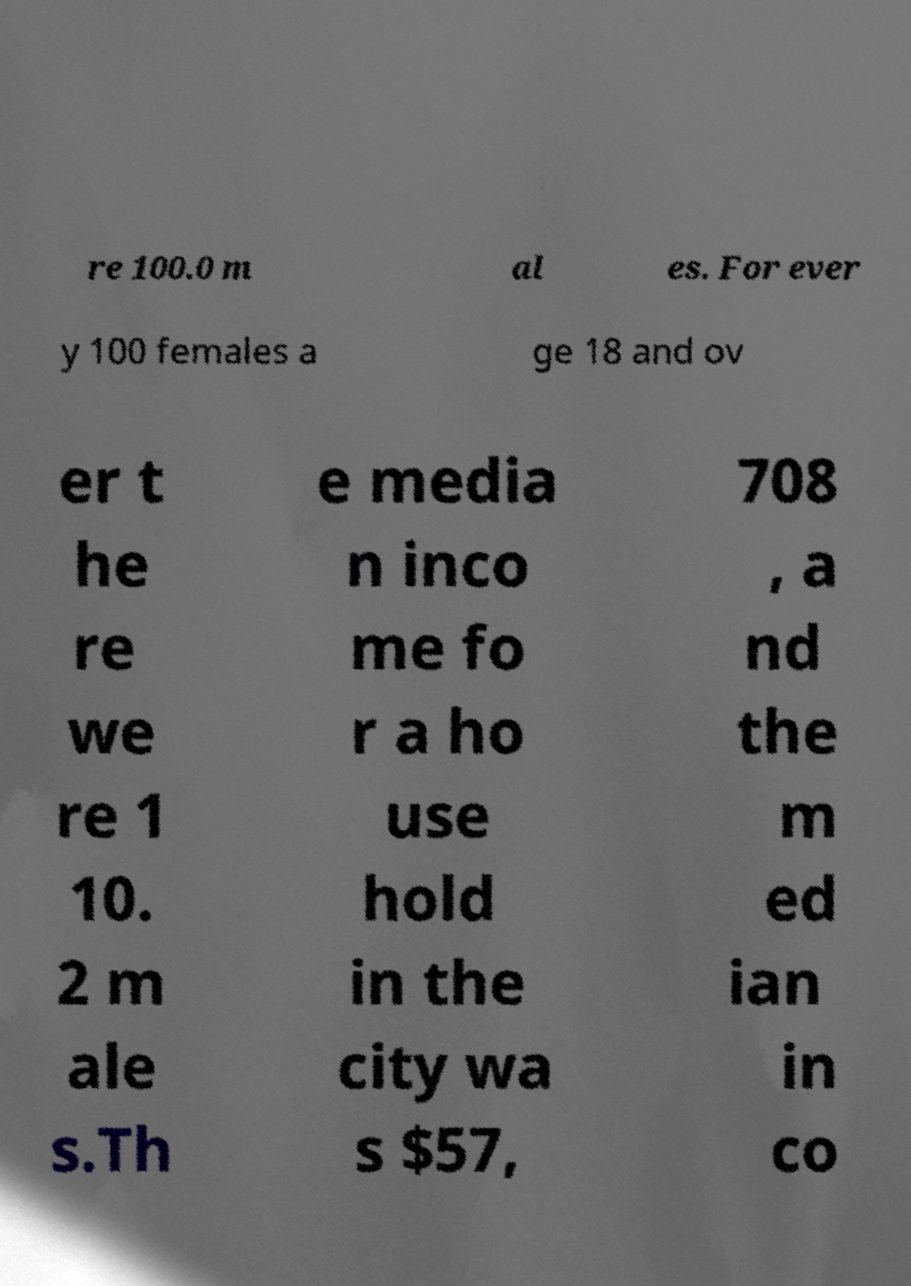Please read and relay the text visible in this image. What does it say? re 100.0 m al es. For ever y 100 females a ge 18 and ov er t he re we re 1 10. 2 m ale s.Th e media n inco me fo r a ho use hold in the city wa s $57, 708 , a nd the m ed ian in co 